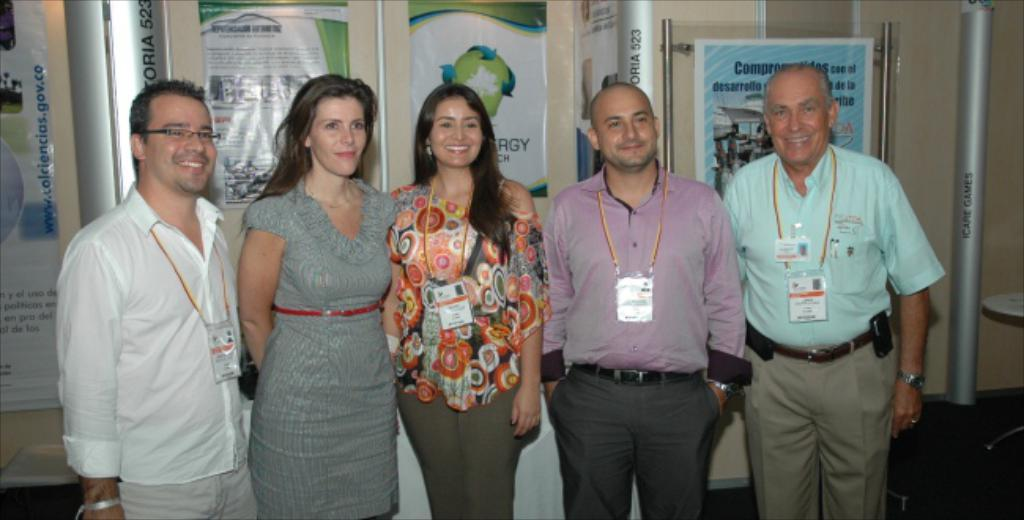How many people are in the group that is visible in the image? There is a group of people standing in the image, but the exact number is not specified. What surface are the people standing on? The people are standing on the floor. What is the main piece of furniture in the image? There is a table in the image. What are the poles used for in the image? The purpose of the poles is not specified, but they are present in the image. What is written on the banners in the image? There are banners with text in the image, but the specific text is not mentioned. What type of structure can be seen in the background of the image? There is a wall in the image. Can you describe the thickness of the fog in the image? There is no fog present in the image. How many women are in the group of people in the image? The gender of the people in the group is not specified, so we cannot determine the number of women. 